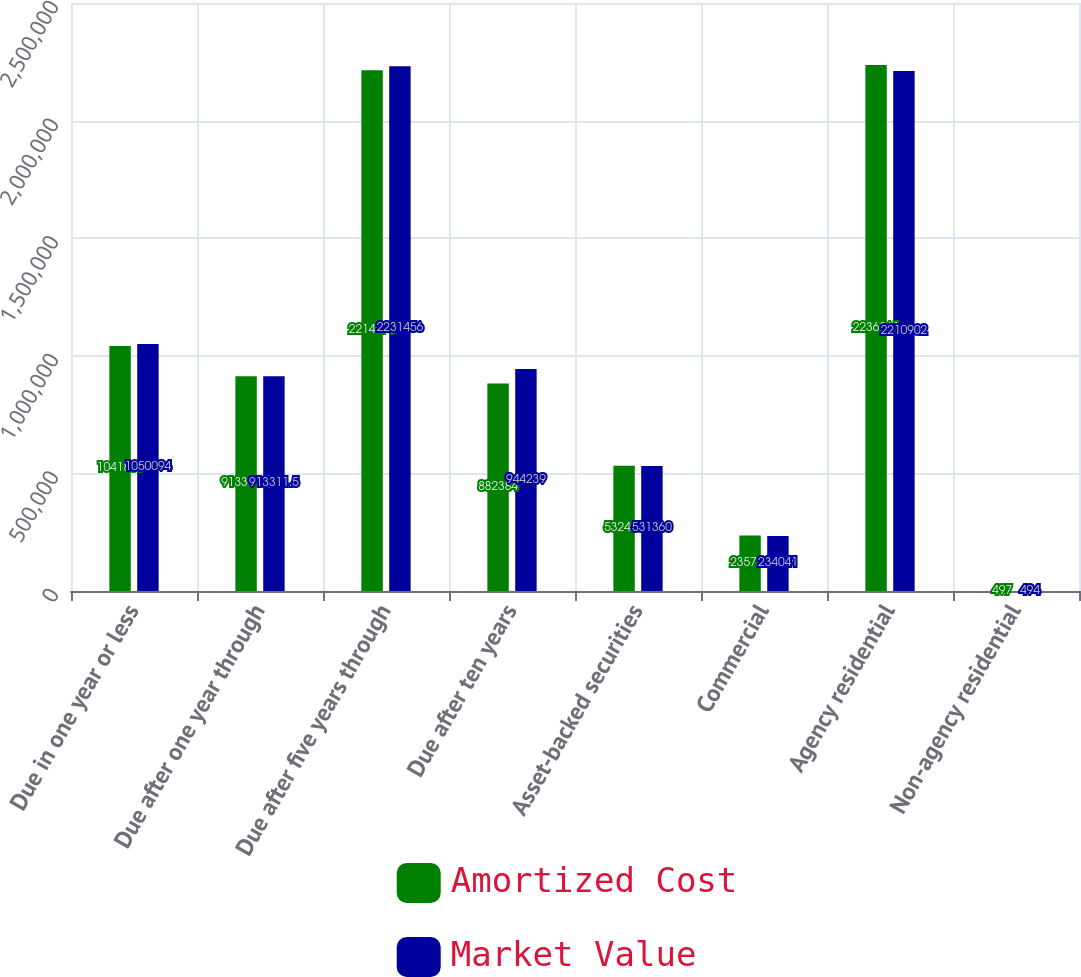Convert chart to OTSL. <chart><loc_0><loc_0><loc_500><loc_500><stacked_bar_chart><ecel><fcel>Due in one year or less<fcel>Due after one year through<fcel>Due after five years through<fcel>Due after ten years<fcel>Asset-backed securities<fcel>Commercial<fcel>Agency residential<fcel>Non-agency residential<nl><fcel>Amortized Cost<fcel>1.04188e+06<fcel>913312<fcel>2.21447e+06<fcel>882384<fcel>532473<fcel>235794<fcel>2.23636e+06<fcel>497<nl><fcel>Market Value<fcel>1.05009e+06<fcel>913312<fcel>2.23146e+06<fcel>944239<fcel>531360<fcel>234041<fcel>2.2109e+06<fcel>494<nl></chart> 